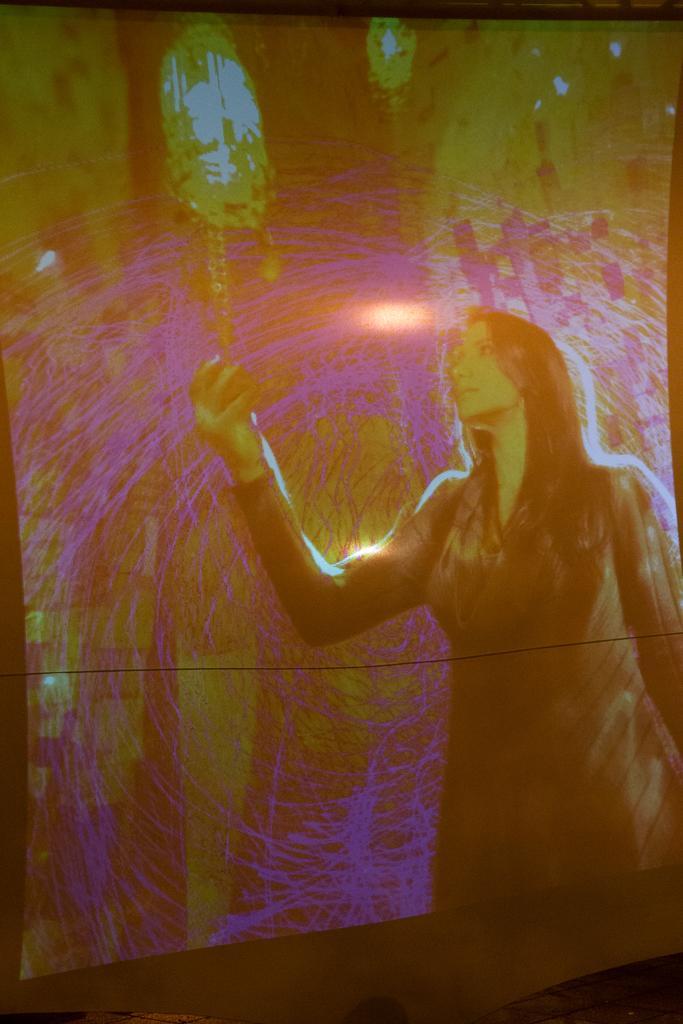Could you give a brief overview of what you see in this image? In the foreground I can see a wall painting in which I can see a woman is holding an object in hand. This image is taken may be in a hall. 